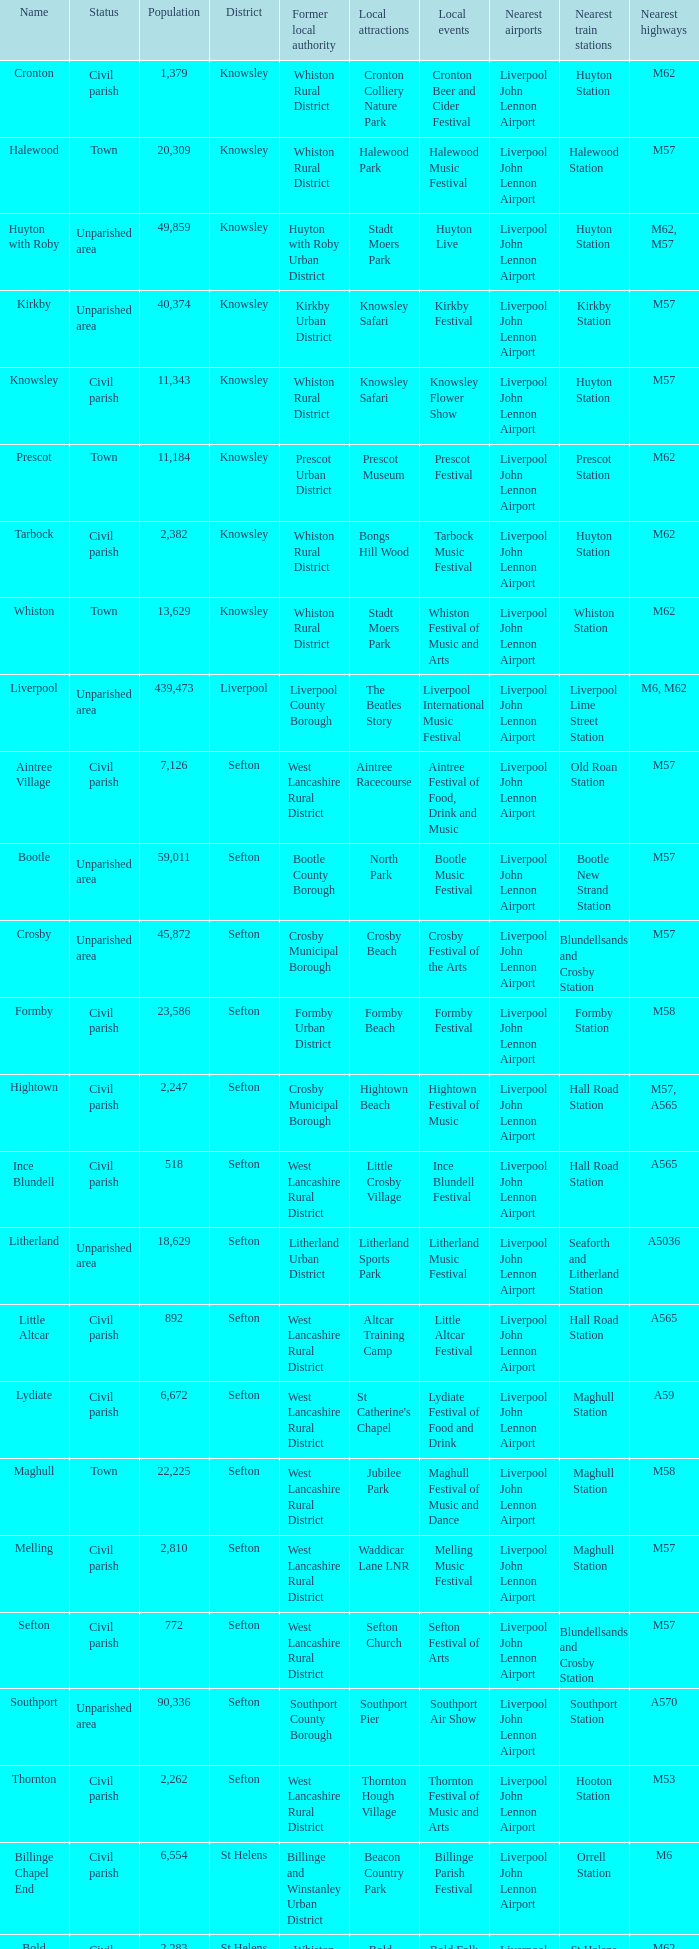Could you parse the entire table as a dict? {'header': ['Name', 'Status', 'Population', 'District', 'Former local authority', 'Local attractions', 'Local events', 'Nearest airports', 'Nearest train stations', 'Nearest highways'], 'rows': [['Cronton', 'Civil parish', '1,379', 'Knowsley', 'Whiston Rural District', 'Cronton Colliery Nature Park', 'Cronton Beer and Cider Festival', 'Liverpool John Lennon Airport', 'Huyton Station', 'M62'], ['Halewood', 'Town', '20,309', 'Knowsley', 'Whiston Rural District', 'Halewood Park', 'Halewood Music Festival', 'Liverpool John Lennon Airport', 'Halewood Station', 'M57'], ['Huyton with Roby', 'Unparished area', '49,859', 'Knowsley', 'Huyton with Roby Urban District', 'Stadt Moers Park', 'Huyton Live', 'Liverpool John Lennon Airport', 'Huyton Station', 'M62, M57'], ['Kirkby', 'Unparished area', '40,374', 'Knowsley', 'Kirkby Urban District', 'Knowsley Safari', 'Kirkby Festival', 'Liverpool John Lennon Airport', 'Kirkby Station', 'M57'], ['Knowsley', 'Civil parish', '11,343', 'Knowsley', 'Whiston Rural District', 'Knowsley Safari', 'Knowsley Flower Show', 'Liverpool John Lennon Airport', 'Huyton Station', 'M57'], ['Prescot', 'Town', '11,184', 'Knowsley', 'Prescot Urban District', 'Prescot Museum', 'Prescot Festival', 'Liverpool John Lennon Airport', 'Prescot Station', 'M62'], ['Tarbock', 'Civil parish', '2,382', 'Knowsley', 'Whiston Rural District', 'Bongs Hill Wood', 'Tarbock Music Festival', 'Liverpool John Lennon Airport', 'Huyton Station', 'M62'], ['Whiston', 'Town', '13,629', 'Knowsley', 'Whiston Rural District', 'Stadt Moers Park', 'Whiston Festival of Music and Arts', 'Liverpool John Lennon Airport', 'Whiston Station', 'M62'], ['Liverpool', 'Unparished area', '439,473', 'Liverpool', 'Liverpool County Borough', 'The Beatles Story', 'Liverpool International Music Festival', 'Liverpool John Lennon Airport', 'Liverpool Lime Street Station', 'M6, M62'], ['Aintree Village', 'Civil parish', '7,126', 'Sefton', 'West Lancashire Rural District', 'Aintree Racecourse', 'Aintree Festival of Food, Drink and Music', 'Liverpool John Lennon Airport', 'Old Roan Station', 'M57'], ['Bootle', 'Unparished area', '59,011', 'Sefton', 'Bootle County Borough', 'North Park', 'Bootle Music Festival', 'Liverpool John Lennon Airport', 'Bootle New Strand Station', 'M57'], ['Crosby', 'Unparished area', '45,872', 'Sefton', 'Crosby Municipal Borough', 'Crosby Beach', 'Crosby Festival of the Arts', 'Liverpool John Lennon Airport', 'Blundellsands and Crosby Station', 'M57'], ['Formby', 'Civil parish', '23,586', 'Sefton', 'Formby Urban District', 'Formby Beach', 'Formby Festival', 'Liverpool John Lennon Airport', 'Formby Station', 'M58'], ['Hightown', 'Civil parish', '2,247', 'Sefton', 'Crosby Municipal Borough', 'Hightown Beach', 'Hightown Festival of Music', 'Liverpool John Lennon Airport', 'Hall Road Station', 'M57, A565'], ['Ince Blundell', 'Civil parish', '518', 'Sefton', 'West Lancashire Rural District', 'Little Crosby Village', 'Ince Blundell Festival', 'Liverpool John Lennon Airport', 'Hall Road Station', 'A565'], ['Litherland', 'Unparished area', '18,629', 'Sefton', 'Litherland Urban District', 'Litherland Sports Park', 'Litherland Music Festival', 'Liverpool John Lennon Airport', 'Seaforth and Litherland Station', 'A5036'], ['Little Altcar', 'Civil parish', '892', 'Sefton', 'West Lancashire Rural District', 'Altcar Training Camp', 'Little Altcar Festival', 'Liverpool John Lennon Airport', 'Hall Road Station', 'A565'], ['Lydiate', 'Civil parish', '6,672', 'Sefton', 'West Lancashire Rural District', "St Catherine's Chapel", 'Lydiate Festival of Food and Drink', 'Liverpool John Lennon Airport', 'Maghull Station', 'A59'], ['Maghull', 'Town', '22,225', 'Sefton', 'West Lancashire Rural District', 'Jubilee Park', 'Maghull Festival of Music and Dance', 'Liverpool John Lennon Airport', 'Maghull Station', 'M58'], ['Melling', 'Civil parish', '2,810', 'Sefton', 'West Lancashire Rural District', 'Waddicar Lane LNR', 'Melling Music Festival', 'Liverpool John Lennon Airport', 'Maghull Station', 'M57'], ['Sefton', 'Civil parish', '772', 'Sefton', 'West Lancashire Rural District', 'Sefton Church', 'Sefton Festival of Arts', 'Liverpool John Lennon Airport', 'Blundellsands and Crosby Station', 'M57'], ['Southport', 'Unparished area', '90,336', 'Sefton', 'Southport County Borough', 'Southport Pier', 'Southport Air Show', 'Liverpool John Lennon Airport', 'Southport Station', 'A570'], ['Thornton', 'Civil parish', '2,262', 'Sefton', 'West Lancashire Rural District', 'Thornton Hough Village', 'Thornton Festival of Music and Arts', 'Liverpool John Lennon Airport', 'Hooton Station', 'M53'], ['Billinge Chapel End', 'Civil parish', '6,554', 'St Helens', 'Billinge and Winstanley Urban District', 'Beacon Country Park', 'Billinge Parish Festival', 'Liverpool John Lennon Airport', 'Orrell Station', 'M6'], ['Bold', 'Civil parish', '2,283', 'St Helens', 'Whiston Rural District', 'Bold Forest Park', 'Bold Folk Festival', 'Liverpool John Lennon Airport', 'St Helens Junction Station', 'M62'], ['Eccleston', 'Civil parish', '10,528', 'St Helens', 'Whiston Rural District', 'Sherdley Park', 'Eccleston Music Festival', 'Liverpool John Lennon Airport', 'Eccleston Park Station', 'M6'], ['Haydock', 'Unparished area', '15,684', 'St Helens', 'Haydock Urban District', 'Haydock Park Racecourse', 'Haydock Music Festival', 'Liverpool John Lennon Airport', 'Newton le Willows Station', 'M6'], ['Newton le Willows', 'Unparished area', '21,418', 'St Helens', 'Newton le Willows Urban District', 'Sankey Valley Park', 'Newton le Willows Festival', 'Liverpool John Lennon Airport', 'Newton le Willows Station', 'M6'], ['Rainford', 'Civil parish', '8,344', 'St Helens', 'Rainford Urban District', 'Rainford Junction LNR', 'Rainford Music Festival', 'Liverpool John Lennon Airport', 'Rainford Station', 'A570'], ['Rainhill', 'Civil parish', '11,913', 'St Helens', 'Whiston Rural District', 'Stadt Moers Park', 'Rainhill Carnival', 'Liverpool John Lennon Airport', 'Rainhill Station', 'M62'], ['Seneley Green', 'Civil parish', '6,163', 'St Helens', 'Ashton in Makerfield Urban District', 'St Helens Canal', 'Seneley Green Festival of the Arts', 'Liverpool John Lennon Airport', 'St Helens Junction Station', 'M6'], ['St Helens', 'Unparished area', '91,414', 'St Helens', 'St Helens County Borough', 'Taylor Park', 'St Helens Festival of Music and Arts', 'Liverpool John Lennon Airport', 'St Helens Central Station', 'M6, M62'], ['Windle', 'Civil parish', '2,542', 'St Helens', 'Whiston Rural District', 'Colliers Moss Common', 'Windle Festival', 'Liverpool John Lennon Airport', 'Lea Green Station', 'M62'], ['Bebington', 'Unparished area', '58,226', 'Wirral', 'Bebington Municipal Borough', 'Port Sunlight Museum and Garden Village', 'Bebington Food and Drink Festival', 'Liverpool John Lennon Airport', 'Bebington Station', 'M53'], ['Birkenhead', 'Unparished area', '103,206', 'Wirral', 'Birkenhead County Borough', 'Williamson Art Gallery and Museum', 'International Mersey River Festival', 'Liverpool John Lennon Airport', 'Birkenhead Central Station', 'M53'], ['Heswall', 'Unparished area', '29,977', 'Wirral', 'Wirral Urban District', 'Heswall Dales', 'Heswall Arts Festival', 'Liverpool John Lennon Airport', 'Heswall Station', 'A540'], ['Hoylake', 'Unparished area', '35,655', 'Wirral', 'Hoylake Urban District', 'Royal Liverpool Golf Club', 'Hoylake and West Kirby Arts Festival', 'Liverpool John Lennon Airport', 'Hoylake Station', 'A540'], ['Wallasey', 'Unparished area', '84,348', 'Wirral', 'Wallasey County Borough', 'New Brighton Beach', 'Wirral Food and Drink Festival', 'Liverpool John Lennon Airport', 'Wallasey Grove Road Station', 'M53']]} What is the district of wallasey Wirral. 